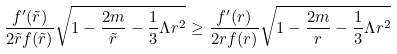Convert formula to latex. <formula><loc_0><loc_0><loc_500><loc_500>\frac { f ^ { \prime } ( \tilde { r } ) } { 2 \tilde { r } f ( \tilde { r } ) } \sqrt { 1 - \frac { 2 m } { \tilde { r } } - \frac { 1 } { 3 } \Lambda r ^ { 2 } } \geq \frac { f ^ { \prime } ( r ) } { 2 r f ( r ) } \sqrt { 1 - \frac { 2 m } { r } - \frac { 1 } { 3 } \Lambda r ^ { 2 } }</formula> 